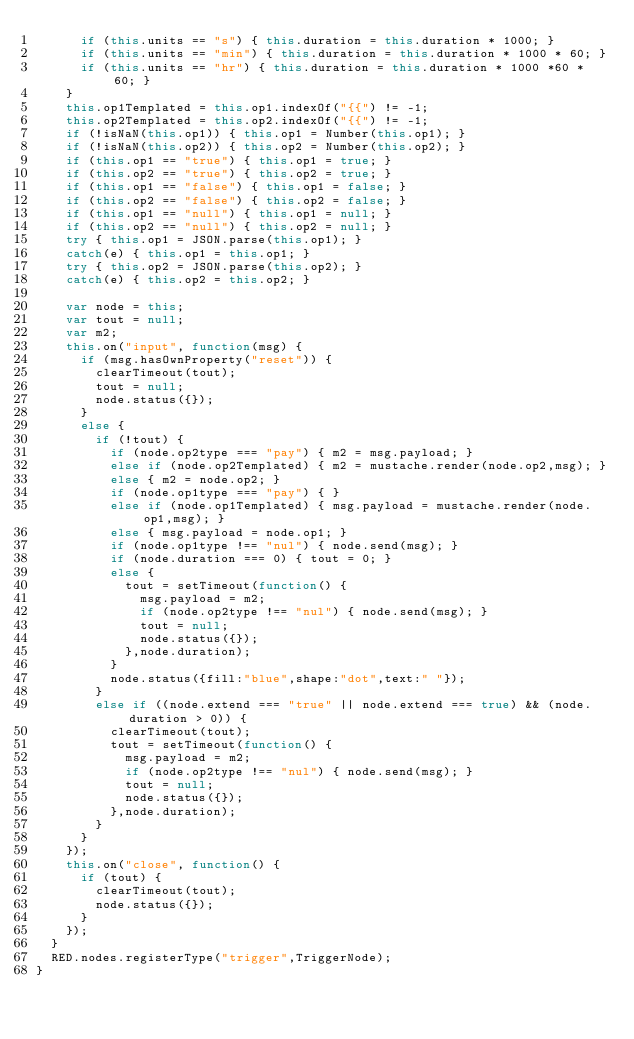<code> <loc_0><loc_0><loc_500><loc_500><_JavaScript_>      if (this.units == "s") { this.duration = this.duration * 1000; }
      if (this.units == "min") { this.duration = this.duration * 1000 * 60; }
      if (this.units == "hr") { this.duration = this.duration * 1000 *60 * 60; }
    }
    this.op1Templated = this.op1.indexOf("{{") != -1;
    this.op2Templated = this.op2.indexOf("{{") != -1;
    if (!isNaN(this.op1)) { this.op1 = Number(this.op1); }
    if (!isNaN(this.op2)) { this.op2 = Number(this.op2); }
    if (this.op1 == "true") { this.op1 = true; }
    if (this.op2 == "true") { this.op2 = true; }
    if (this.op1 == "false") { this.op1 = false; }
    if (this.op2 == "false") { this.op2 = false; }
    if (this.op1 == "null") { this.op1 = null; }
    if (this.op2 == "null") { this.op2 = null; }
    try { this.op1 = JSON.parse(this.op1); }
    catch(e) { this.op1 = this.op1; }
    try { this.op2 = JSON.parse(this.op2); }
    catch(e) { this.op2 = this.op2; }

    var node = this;
    var tout = null;
    var m2;
    this.on("input", function(msg) {
      if (msg.hasOwnProperty("reset")) {
        clearTimeout(tout);
        tout = null;
        node.status({});
      }
      else {
        if (!tout) {
          if (node.op2type === "pay") { m2 = msg.payload; }
          else if (node.op2Templated) { m2 = mustache.render(node.op2,msg); }
          else { m2 = node.op2; }
          if (node.op1type === "pay") { }
          else if (node.op1Templated) { msg.payload = mustache.render(node.op1,msg); }
          else { msg.payload = node.op1; }
          if (node.op1type !== "nul") { node.send(msg); }
          if (node.duration === 0) { tout = 0; }
          else {
            tout = setTimeout(function() {
              msg.payload = m2;
              if (node.op2type !== "nul") { node.send(msg); }
              tout = null;
              node.status({});
            },node.duration);
          }
          node.status({fill:"blue",shape:"dot",text:" "});
        }
        else if ((node.extend === "true" || node.extend === true) && (node.duration > 0)) {
          clearTimeout(tout);
          tout = setTimeout(function() {
            msg.payload = m2;
            if (node.op2type !== "nul") { node.send(msg); }
            tout = null;
            node.status({});
          },node.duration);
        }
      }
    });
    this.on("close", function() {
      if (tout) {
        clearTimeout(tout);
        node.status({});
      }
    });
  }
  RED.nodes.registerType("trigger",TriggerNode);
}

</code> 